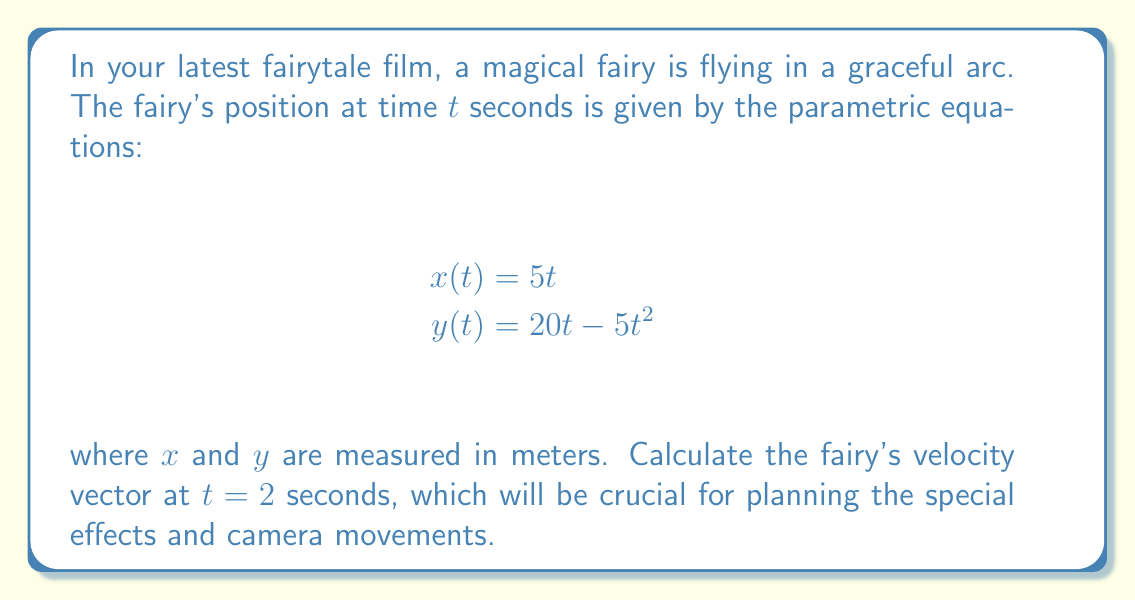Help me with this question. To find the fairy's velocity vector at $t = 2$ seconds, we need to follow these steps:

1) The velocity vector is given by $\vec{v}(t) = \langle \frac{dx}{dt}, \frac{dy}{dt} \rangle$

2) Find $\frac{dx}{dt}$:
   $$\frac{dx}{dt} = \frac{d}{dt}(5t) = 5$$

3) Find $\frac{dy}{dt}$:
   $$\frac{dy}{dt} = \frac{d}{dt}(20t - 5t^2) = 20 - 10t$$

4) Therefore, the velocity vector is:
   $$\vec{v}(t) = \langle 5, 20 - 10t \rangle$$

5) At $t = 2$ seconds:
   $$\vec{v}(2) = \langle 5, 20 - 10(2) \rangle = \langle 5, 20 - 20 \rangle = \langle 5, 0 \rangle$$

Thus, at $t = 2$ seconds, the fairy's velocity vector is $\langle 5, 0 \rangle$ meters per second.
Answer: $\langle 5, 0 \rangle$ m/s 